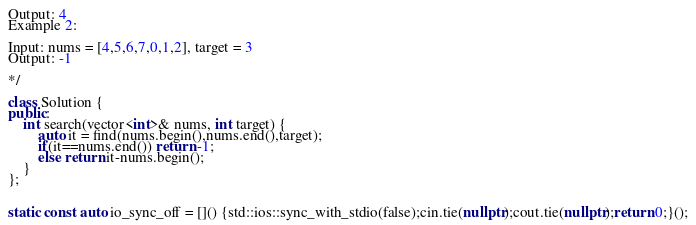<code> <loc_0><loc_0><loc_500><loc_500><_C++_>Output: 4
Example 2:

Input: nums = [4,5,6,7,0,1,2], target = 3
Output: -1

*/

class Solution {
public:
    int search(vector<int>& nums, int target) {
        auto it = find(nums.begin(),nums.end(),target);
        if(it==nums.end()) return -1;
        else return it-nums.begin();
    }
};


static const auto io_sync_off = []() {std::ios::sync_with_stdio(false);cin.tie(nullptr);cout.tie(nullptr);return 0;}();</code> 